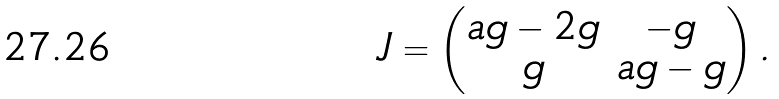Convert formula to latex. <formula><loc_0><loc_0><loc_500><loc_500>J = \begin{pmatrix} a g - 2 g & - g \\ g & a g - g \end{pmatrix} .</formula> 